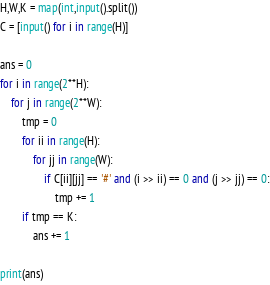<code> <loc_0><loc_0><loc_500><loc_500><_Python_>H,W,K = map(int,input().split())
C = [input() for i in range(H)]

ans = 0
for i in range(2**H):
    for j in range(2**W):
        tmp = 0
        for ii in range(H):
            for jj in range(W):
                if C[ii][jj] == '#' and (i >> ii) == 0 and (j >> jj) == 0:
                    tmp += 1
        if tmp == K:
            ans += 1
            
print(ans)    </code> 